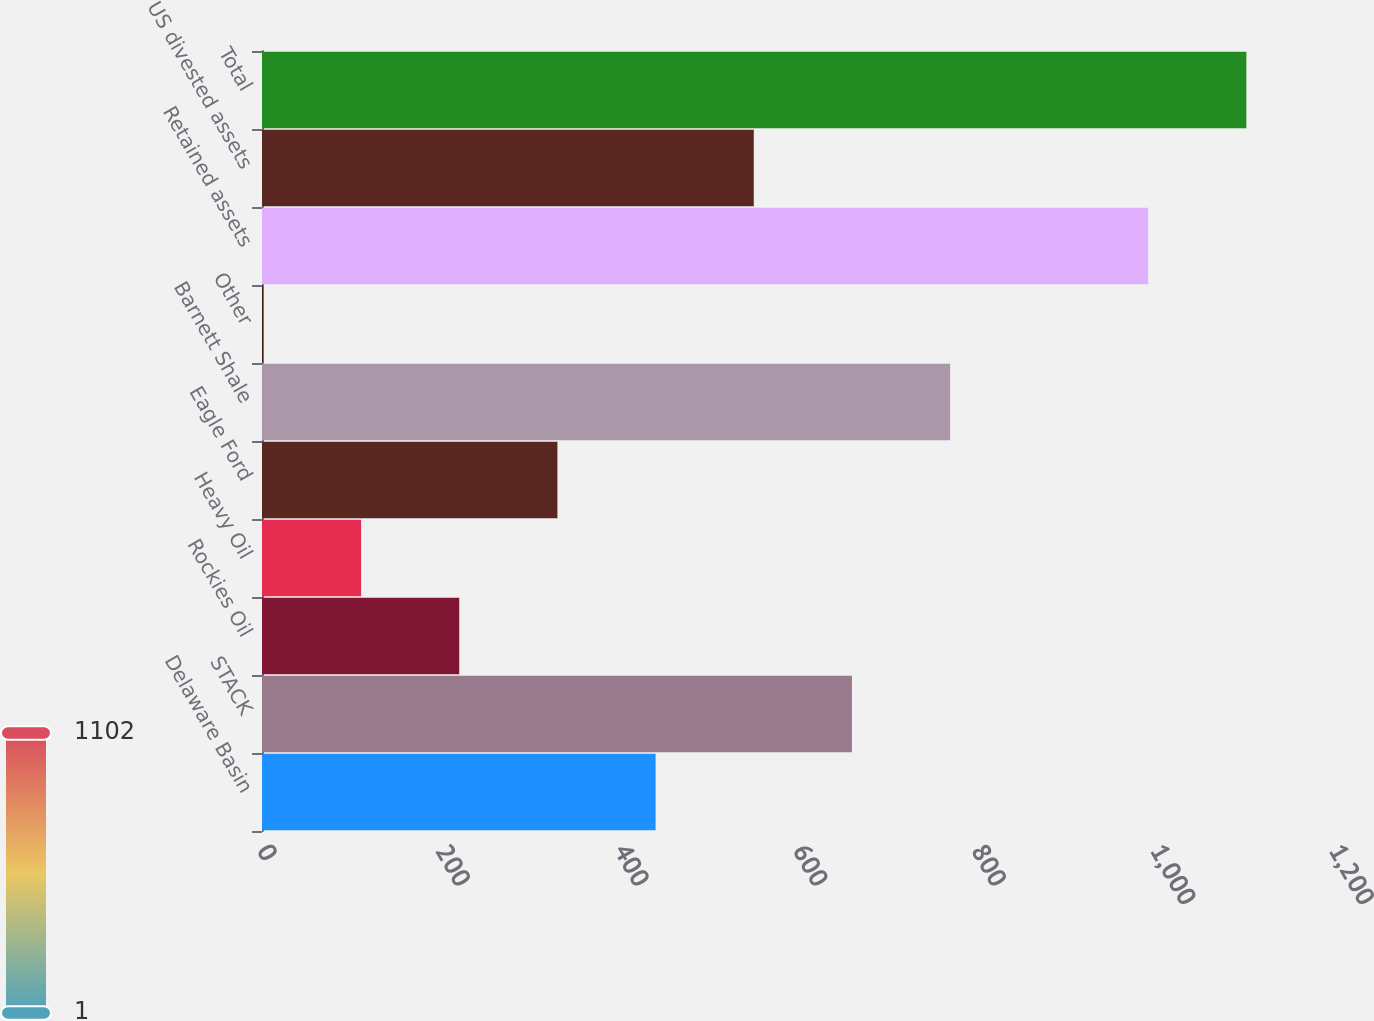Convert chart to OTSL. <chart><loc_0><loc_0><loc_500><loc_500><bar_chart><fcel>Delaware Basin<fcel>STACK<fcel>Rockies Oil<fcel>Heavy Oil<fcel>Eagle Ford<fcel>Barnett Shale<fcel>Other<fcel>Retained assets<fcel>US divested assets<fcel>Total<nl><fcel>440.6<fcel>660.4<fcel>220.8<fcel>110.9<fcel>330.7<fcel>770.3<fcel>1<fcel>992<fcel>550.5<fcel>1101.9<nl></chart> 